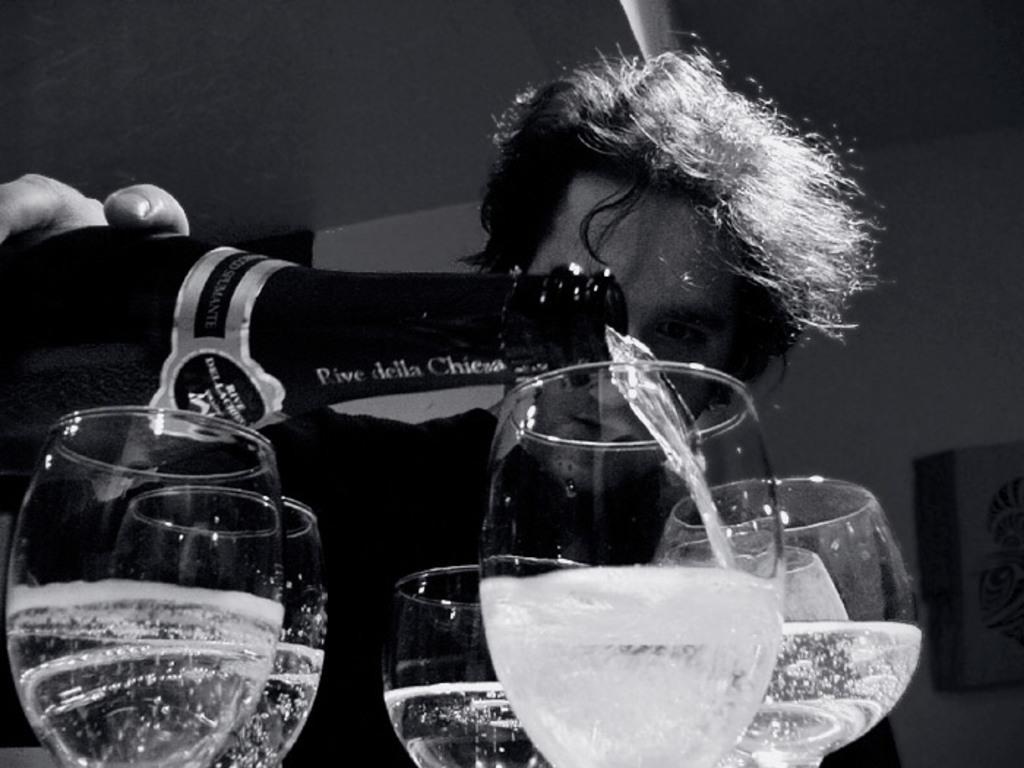Can you describe this image briefly? In this picture I can see six glasses of wine , there is a person holding a bottle and pouring wine into one of the glass, and in the background there is a wall. 